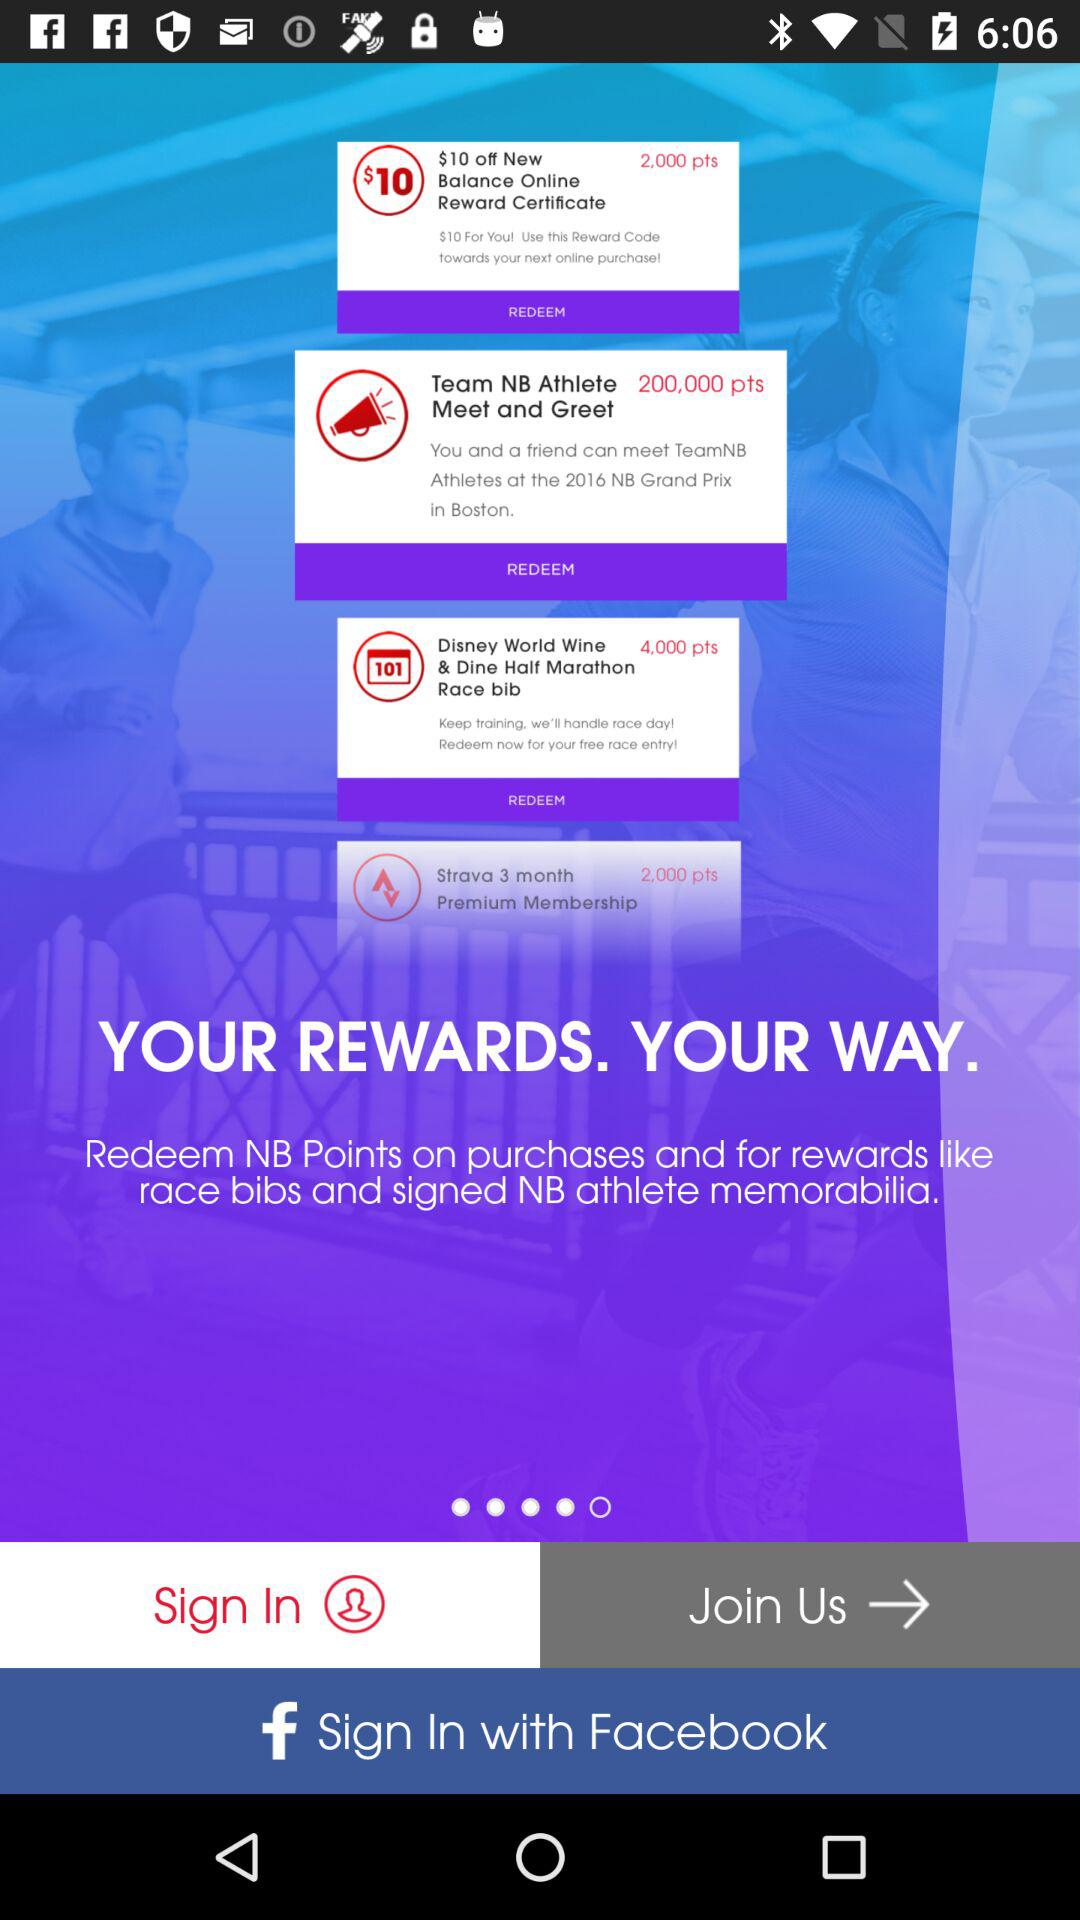What other application can be used to sign in to the profile? The other application that can be used to sign in to the profile is "Facebook". 